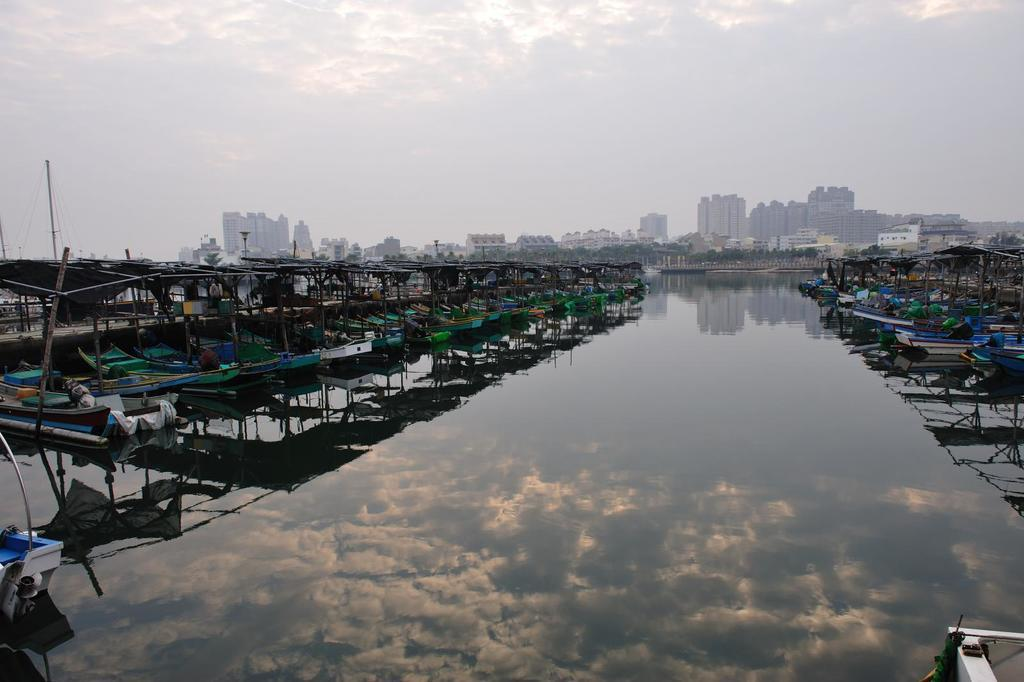What is the main subject of the image? The main subject of the image is many boats. Where are the boats located? The boats are on the water. How can the boats be described in terms of appearance? The boats are colorful. What can be seen in the background of the image? There are trees, buildings, clouds, and the sky visible in the background of the image. What type of sink can be seen in the image? There is no sink present in the image; it features many boats on the water with a background of trees, buildings, clouds, and the sky. 